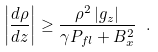Convert formula to latex. <formula><loc_0><loc_0><loc_500><loc_500>\left | \frac { d \rho } { d z } \right | \geq \frac { \rho ^ { 2 } \left | g _ { z } \right | } { \gamma P _ { f l } + B _ { x } ^ { 2 } } \ .</formula> 